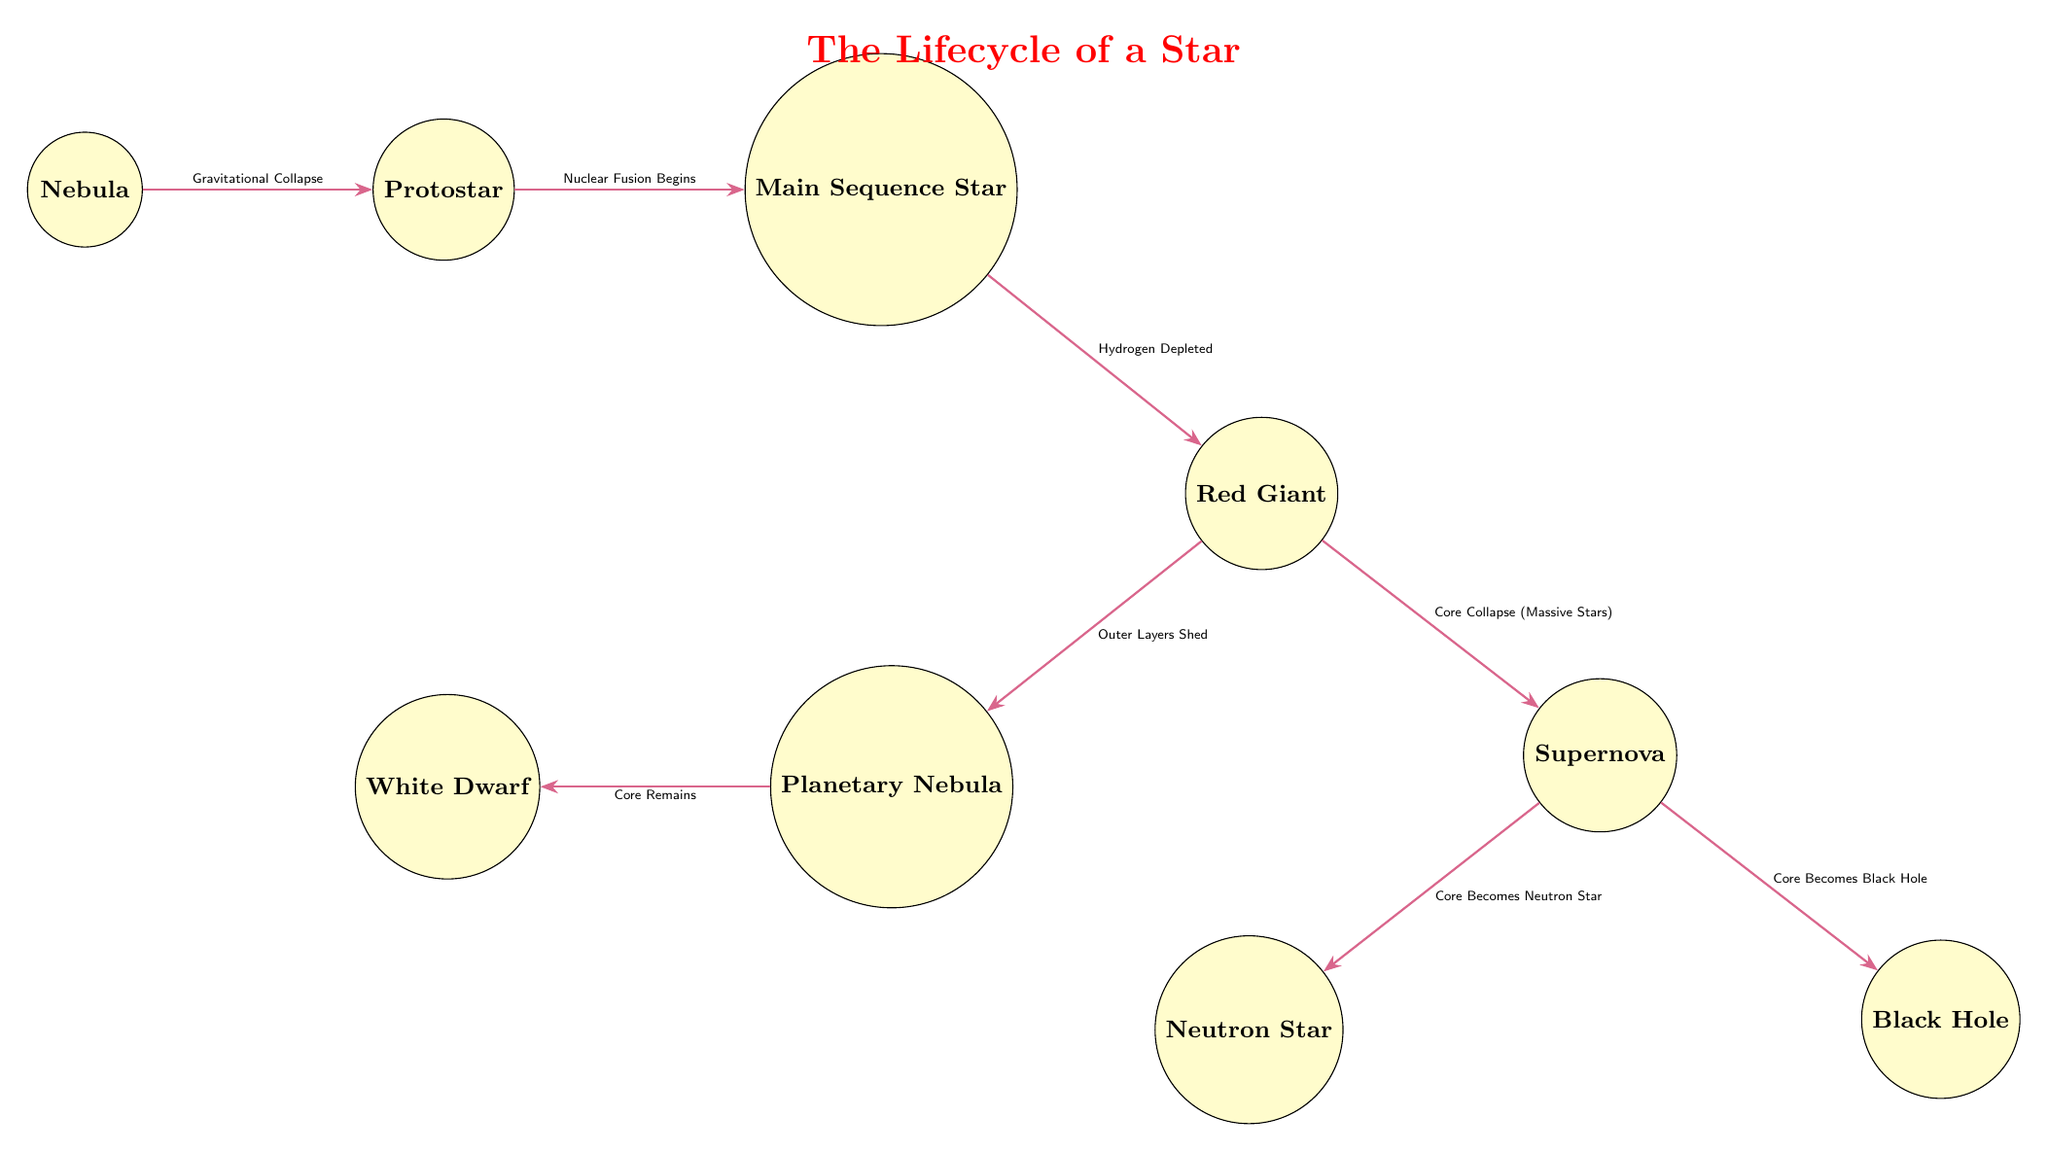What is the first stage of a star's lifecycle? The diagram clearly shows that the first stage is labeled as "Nebula". This node is positioned at the far left, indicating that it is the starting point of the star lifecycle progression.
Answer: Nebula How many stages are there in the lifecycle of a star? The diagram includes a total of 8 distinct nodes, which represent the different stages a star goes through, starting from the nebula to either a neutron star or a black hole.
Answer: 8 What happens after a Main Sequence Star? According to the diagram, after the Main Sequence Star, the next stage is indicated as "Red Giant". This transition is facilitated by the depletion of hydrogen in the star's core.
Answer: Red Giant Which stage results in a Supernova for massive stars? The diagram specifies that the "Red Giant" stage leads to a "Supernova" for massive stars when a core collapse occurs. This relationship is explicitly shown with an arrow connecting these two stages.
Answer: Red Giant What process initiates the transition from Nebula to Protostar? The label on the arrow leading from the "Nebula" to the "Protostar" identifies the process as "Gravitational Collapse". This indicates the action that triggers the formation of a protostar from the nebula.
Answer: Gravitational Collapse What is formed after the Planetary Nebula stage? From the diagram, it is clear that after the "Planetary Nebula", the core that remains becomes a "White Dwarf". This transition is represented by an arrow pointing to the white dwarf node.
Answer: White Dwarf What are the final two possible outcomes after a Supernova? The diagram shows that a Supernova can lead to two distinct outcomes: a "Neutron Star" or a "Black Hole". These outcomes are represented as branches below the Supernova stage.
Answer: Neutron Star, Black Hole Which term describes the process when nuclear fusion begins? The diagram labels the process that initiates the transition from a Protostar to a Main Sequence Star as "Nuclear Fusion Begins". This action is crucial for a star to enter the main sequence phase.
Answer: Nuclear Fusion Begins What happens to the outer layers of a red giant? The diagram indicates that during the transition from Red Giant to Planetary Nebula, the outer layers are shed. This key detail is highlighted in the label associated with the arrow between these two stages.
Answer: Outer Layers Shed 